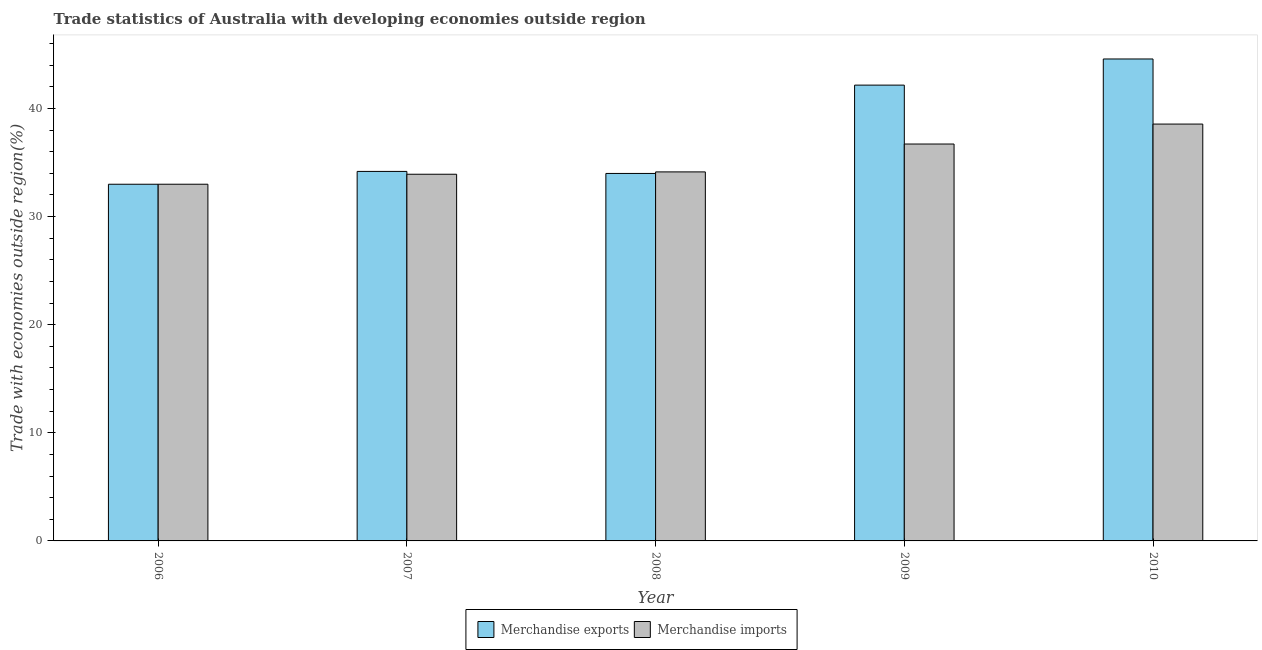How many different coloured bars are there?
Ensure brevity in your answer.  2. How many groups of bars are there?
Offer a terse response. 5. Are the number of bars on each tick of the X-axis equal?
Offer a terse response. Yes. How many bars are there on the 5th tick from the right?
Your answer should be compact. 2. In how many cases, is the number of bars for a given year not equal to the number of legend labels?
Ensure brevity in your answer.  0. What is the merchandise imports in 2007?
Your answer should be very brief. 33.92. Across all years, what is the maximum merchandise exports?
Offer a terse response. 44.58. Across all years, what is the minimum merchandise exports?
Offer a very short reply. 32.99. In which year was the merchandise exports minimum?
Give a very brief answer. 2006. What is the total merchandise exports in the graph?
Ensure brevity in your answer.  187.91. What is the difference between the merchandise exports in 2006 and that in 2010?
Your answer should be compact. -11.59. What is the difference between the merchandise exports in 2006 and the merchandise imports in 2010?
Offer a terse response. -11.59. What is the average merchandise imports per year?
Keep it short and to the point. 35.27. What is the ratio of the merchandise exports in 2006 to that in 2007?
Offer a terse response. 0.97. Is the merchandise imports in 2008 less than that in 2010?
Your answer should be compact. Yes. Is the difference between the merchandise exports in 2006 and 2008 greater than the difference between the merchandise imports in 2006 and 2008?
Ensure brevity in your answer.  No. What is the difference between the highest and the second highest merchandise imports?
Your answer should be very brief. 1.84. What is the difference between the highest and the lowest merchandise exports?
Offer a terse response. 11.59. In how many years, is the merchandise exports greater than the average merchandise exports taken over all years?
Offer a terse response. 2. What does the 2nd bar from the left in 2008 represents?
Your answer should be very brief. Merchandise imports. Are all the bars in the graph horizontal?
Make the answer very short. No. Are the values on the major ticks of Y-axis written in scientific E-notation?
Your answer should be very brief. No. Does the graph contain any zero values?
Make the answer very short. No. How many legend labels are there?
Your answer should be very brief. 2. What is the title of the graph?
Offer a terse response. Trade statistics of Australia with developing economies outside region. Does "Resident" appear as one of the legend labels in the graph?
Your answer should be very brief. No. What is the label or title of the Y-axis?
Provide a short and direct response. Trade with economies outside region(%). What is the Trade with economies outside region(%) of Merchandise exports in 2006?
Give a very brief answer. 32.99. What is the Trade with economies outside region(%) in Merchandise imports in 2006?
Your answer should be compact. 33. What is the Trade with economies outside region(%) in Merchandise exports in 2007?
Give a very brief answer. 34.18. What is the Trade with economies outside region(%) in Merchandise imports in 2007?
Offer a terse response. 33.92. What is the Trade with economies outside region(%) in Merchandise exports in 2008?
Your response must be concise. 33.99. What is the Trade with economies outside region(%) of Merchandise imports in 2008?
Your answer should be very brief. 34.14. What is the Trade with economies outside region(%) of Merchandise exports in 2009?
Ensure brevity in your answer.  42.16. What is the Trade with economies outside region(%) in Merchandise imports in 2009?
Ensure brevity in your answer.  36.71. What is the Trade with economies outside region(%) of Merchandise exports in 2010?
Provide a short and direct response. 44.58. What is the Trade with economies outside region(%) of Merchandise imports in 2010?
Your answer should be very brief. 38.56. Across all years, what is the maximum Trade with economies outside region(%) in Merchandise exports?
Provide a short and direct response. 44.58. Across all years, what is the maximum Trade with economies outside region(%) in Merchandise imports?
Give a very brief answer. 38.56. Across all years, what is the minimum Trade with economies outside region(%) of Merchandise exports?
Make the answer very short. 32.99. Across all years, what is the minimum Trade with economies outside region(%) in Merchandise imports?
Your answer should be compact. 33. What is the total Trade with economies outside region(%) in Merchandise exports in the graph?
Provide a succinct answer. 187.91. What is the total Trade with economies outside region(%) of Merchandise imports in the graph?
Give a very brief answer. 176.33. What is the difference between the Trade with economies outside region(%) in Merchandise exports in 2006 and that in 2007?
Your answer should be very brief. -1.19. What is the difference between the Trade with economies outside region(%) of Merchandise imports in 2006 and that in 2007?
Provide a short and direct response. -0.92. What is the difference between the Trade with economies outside region(%) in Merchandise exports in 2006 and that in 2008?
Give a very brief answer. -1. What is the difference between the Trade with economies outside region(%) of Merchandise imports in 2006 and that in 2008?
Your response must be concise. -1.14. What is the difference between the Trade with economies outside region(%) of Merchandise exports in 2006 and that in 2009?
Provide a succinct answer. -9.17. What is the difference between the Trade with economies outside region(%) of Merchandise imports in 2006 and that in 2009?
Your answer should be compact. -3.72. What is the difference between the Trade with economies outside region(%) of Merchandise exports in 2006 and that in 2010?
Give a very brief answer. -11.59. What is the difference between the Trade with economies outside region(%) of Merchandise imports in 2006 and that in 2010?
Provide a succinct answer. -5.56. What is the difference between the Trade with economies outside region(%) of Merchandise exports in 2007 and that in 2008?
Provide a succinct answer. 0.19. What is the difference between the Trade with economies outside region(%) of Merchandise imports in 2007 and that in 2008?
Give a very brief answer. -0.22. What is the difference between the Trade with economies outside region(%) of Merchandise exports in 2007 and that in 2009?
Offer a very short reply. -7.98. What is the difference between the Trade with economies outside region(%) in Merchandise imports in 2007 and that in 2009?
Your response must be concise. -2.8. What is the difference between the Trade with economies outside region(%) of Merchandise exports in 2007 and that in 2010?
Your answer should be very brief. -10.4. What is the difference between the Trade with economies outside region(%) in Merchandise imports in 2007 and that in 2010?
Provide a succinct answer. -4.64. What is the difference between the Trade with economies outside region(%) of Merchandise exports in 2008 and that in 2009?
Ensure brevity in your answer.  -8.17. What is the difference between the Trade with economies outside region(%) of Merchandise imports in 2008 and that in 2009?
Make the answer very short. -2.58. What is the difference between the Trade with economies outside region(%) of Merchandise exports in 2008 and that in 2010?
Ensure brevity in your answer.  -10.59. What is the difference between the Trade with economies outside region(%) of Merchandise imports in 2008 and that in 2010?
Give a very brief answer. -4.42. What is the difference between the Trade with economies outside region(%) of Merchandise exports in 2009 and that in 2010?
Ensure brevity in your answer.  -2.42. What is the difference between the Trade with economies outside region(%) in Merchandise imports in 2009 and that in 2010?
Offer a terse response. -1.84. What is the difference between the Trade with economies outside region(%) of Merchandise exports in 2006 and the Trade with economies outside region(%) of Merchandise imports in 2007?
Keep it short and to the point. -0.93. What is the difference between the Trade with economies outside region(%) in Merchandise exports in 2006 and the Trade with economies outside region(%) in Merchandise imports in 2008?
Provide a succinct answer. -1.14. What is the difference between the Trade with economies outside region(%) of Merchandise exports in 2006 and the Trade with economies outside region(%) of Merchandise imports in 2009?
Provide a short and direct response. -3.72. What is the difference between the Trade with economies outside region(%) of Merchandise exports in 2006 and the Trade with economies outside region(%) of Merchandise imports in 2010?
Provide a short and direct response. -5.57. What is the difference between the Trade with economies outside region(%) of Merchandise exports in 2007 and the Trade with economies outside region(%) of Merchandise imports in 2008?
Offer a terse response. 0.04. What is the difference between the Trade with economies outside region(%) in Merchandise exports in 2007 and the Trade with economies outside region(%) in Merchandise imports in 2009?
Keep it short and to the point. -2.53. What is the difference between the Trade with economies outside region(%) of Merchandise exports in 2007 and the Trade with economies outside region(%) of Merchandise imports in 2010?
Provide a succinct answer. -4.38. What is the difference between the Trade with economies outside region(%) of Merchandise exports in 2008 and the Trade with economies outside region(%) of Merchandise imports in 2009?
Provide a short and direct response. -2.72. What is the difference between the Trade with economies outside region(%) of Merchandise exports in 2008 and the Trade with economies outside region(%) of Merchandise imports in 2010?
Your response must be concise. -4.57. What is the difference between the Trade with economies outside region(%) in Merchandise exports in 2009 and the Trade with economies outside region(%) in Merchandise imports in 2010?
Provide a succinct answer. 3.6. What is the average Trade with economies outside region(%) of Merchandise exports per year?
Provide a succinct answer. 37.58. What is the average Trade with economies outside region(%) of Merchandise imports per year?
Ensure brevity in your answer.  35.27. In the year 2006, what is the difference between the Trade with economies outside region(%) of Merchandise exports and Trade with economies outside region(%) of Merchandise imports?
Make the answer very short. -0. In the year 2007, what is the difference between the Trade with economies outside region(%) in Merchandise exports and Trade with economies outside region(%) in Merchandise imports?
Make the answer very short. 0.26. In the year 2008, what is the difference between the Trade with economies outside region(%) of Merchandise exports and Trade with economies outside region(%) of Merchandise imports?
Your answer should be compact. -0.14. In the year 2009, what is the difference between the Trade with economies outside region(%) in Merchandise exports and Trade with economies outside region(%) in Merchandise imports?
Your response must be concise. 5.45. In the year 2010, what is the difference between the Trade with economies outside region(%) of Merchandise exports and Trade with economies outside region(%) of Merchandise imports?
Your answer should be very brief. 6.02. What is the ratio of the Trade with economies outside region(%) of Merchandise exports in 2006 to that in 2007?
Ensure brevity in your answer.  0.97. What is the ratio of the Trade with economies outside region(%) of Merchandise imports in 2006 to that in 2007?
Give a very brief answer. 0.97. What is the ratio of the Trade with economies outside region(%) in Merchandise exports in 2006 to that in 2008?
Offer a terse response. 0.97. What is the ratio of the Trade with economies outside region(%) in Merchandise imports in 2006 to that in 2008?
Offer a terse response. 0.97. What is the ratio of the Trade with economies outside region(%) of Merchandise exports in 2006 to that in 2009?
Your answer should be compact. 0.78. What is the ratio of the Trade with economies outside region(%) of Merchandise imports in 2006 to that in 2009?
Your response must be concise. 0.9. What is the ratio of the Trade with economies outside region(%) in Merchandise exports in 2006 to that in 2010?
Provide a succinct answer. 0.74. What is the ratio of the Trade with economies outside region(%) of Merchandise imports in 2006 to that in 2010?
Offer a very short reply. 0.86. What is the ratio of the Trade with economies outside region(%) in Merchandise imports in 2007 to that in 2008?
Provide a succinct answer. 0.99. What is the ratio of the Trade with economies outside region(%) in Merchandise exports in 2007 to that in 2009?
Your answer should be very brief. 0.81. What is the ratio of the Trade with economies outside region(%) of Merchandise imports in 2007 to that in 2009?
Keep it short and to the point. 0.92. What is the ratio of the Trade with economies outside region(%) in Merchandise exports in 2007 to that in 2010?
Your response must be concise. 0.77. What is the ratio of the Trade with economies outside region(%) of Merchandise imports in 2007 to that in 2010?
Provide a short and direct response. 0.88. What is the ratio of the Trade with economies outside region(%) of Merchandise exports in 2008 to that in 2009?
Keep it short and to the point. 0.81. What is the ratio of the Trade with economies outside region(%) in Merchandise imports in 2008 to that in 2009?
Make the answer very short. 0.93. What is the ratio of the Trade with economies outside region(%) in Merchandise exports in 2008 to that in 2010?
Keep it short and to the point. 0.76. What is the ratio of the Trade with economies outside region(%) in Merchandise imports in 2008 to that in 2010?
Offer a very short reply. 0.89. What is the ratio of the Trade with economies outside region(%) in Merchandise exports in 2009 to that in 2010?
Provide a succinct answer. 0.95. What is the ratio of the Trade with economies outside region(%) in Merchandise imports in 2009 to that in 2010?
Keep it short and to the point. 0.95. What is the difference between the highest and the second highest Trade with economies outside region(%) of Merchandise exports?
Provide a short and direct response. 2.42. What is the difference between the highest and the second highest Trade with economies outside region(%) of Merchandise imports?
Your answer should be compact. 1.84. What is the difference between the highest and the lowest Trade with economies outside region(%) in Merchandise exports?
Keep it short and to the point. 11.59. What is the difference between the highest and the lowest Trade with economies outside region(%) of Merchandise imports?
Ensure brevity in your answer.  5.56. 